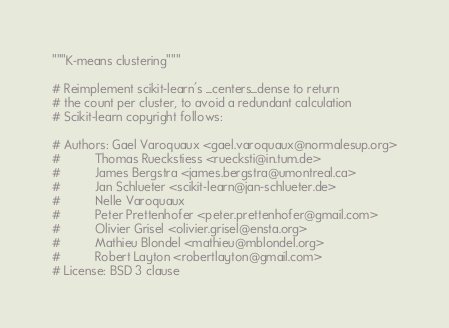<code> <loc_0><loc_0><loc_500><loc_500><_Cython_>"""K-means clustering"""

# Reimplement scikit-learn's _centers_dense to return
# the count per cluster, to avoid a redundant calculation
# Scikit-learn copyright follows:

# Authors: Gael Varoquaux <gael.varoquaux@normalesup.org>
#          Thomas Rueckstiess <ruecksti@in.tum.de>
#          James Bergstra <james.bergstra@umontreal.ca>
#          Jan Schlueter <scikit-learn@jan-schlueter.de>
#          Nelle Varoquaux
#          Peter Prettenhofer <peter.prettenhofer@gmail.com>
#          Olivier Grisel <olivier.grisel@ensta.org>
#          Mathieu Blondel <mathieu@mblondel.org>
#          Robert Layton <robertlayton@gmail.com>
# License: BSD 3 clause</code> 